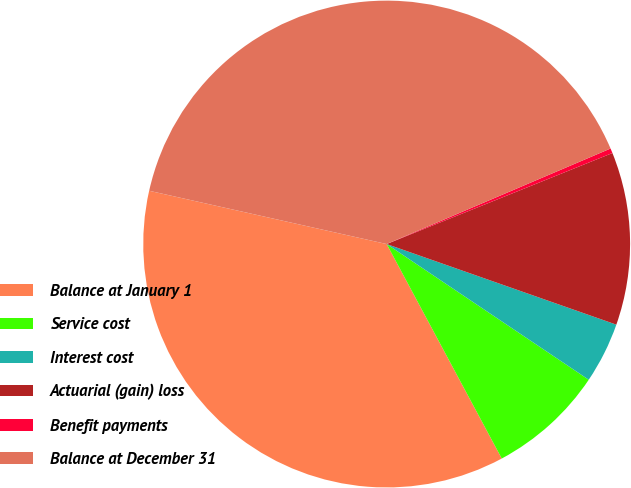Convert chart. <chart><loc_0><loc_0><loc_500><loc_500><pie_chart><fcel>Balance at January 1<fcel>Service cost<fcel>Interest cost<fcel>Actuarial (gain) loss<fcel>Benefit payments<fcel>Balance at December 31<nl><fcel>36.35%<fcel>7.75%<fcel>4.04%<fcel>11.47%<fcel>0.32%<fcel>40.07%<nl></chart> 